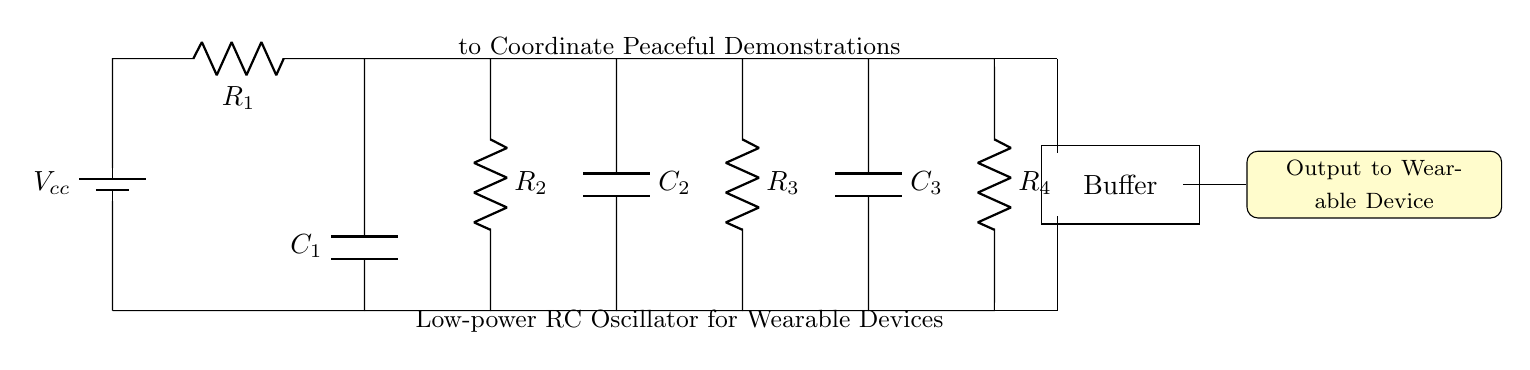What is the total number of resistors in this circuit? There are four resistors labeled as R1, R2, R3, and R4 in the circuit diagram. They are interconnected with capacitors and a battery.
Answer: 4 What is the role of the capacitors in this circuit? The capacitors, labeled C1, C2, and C3, are used for energy storage and to create the timing characteristics necessary for the oscillation. They work in conjunction with the resistors to define the frequency of the oscillator.
Answer: Timing What is the voltage source used in this circuit? The circuit contains a battery that is labeled as Vcc, which serves as the voltage source for powering the oscillator.
Answer: Vcc How many capacitors are present in the circuit? There are three capacitors in the circuit, labeled as C1, C2, and C3 that are connected to the resistors and contribute to the oscillator's functioning.
Answer: 3 What happens when the circuit oscillates? When the circuit oscillates, it generates a periodic signal that can be used to control the wearable device or signal during peaceful demonstrations, thus aiding in coordinated actions.
Answer: Periodic signal Which component acts as a buffer in this circuit? The buffer is identified in the circuit diagram as a rectangular box and is used to isolate the oscillator from the load of the wearable device, providing stability in the output signal.
Answer: Buffer 